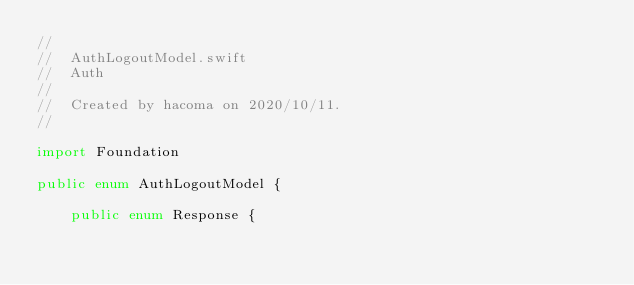Convert code to text. <code><loc_0><loc_0><loc_500><loc_500><_Swift_>//
//  AuthLogoutModel.swift
//  Auth
//
//  Created by hacoma on 2020/10/11.
//

import Foundation

public enum AuthLogoutModel {
    
    public enum Response {
        </code> 